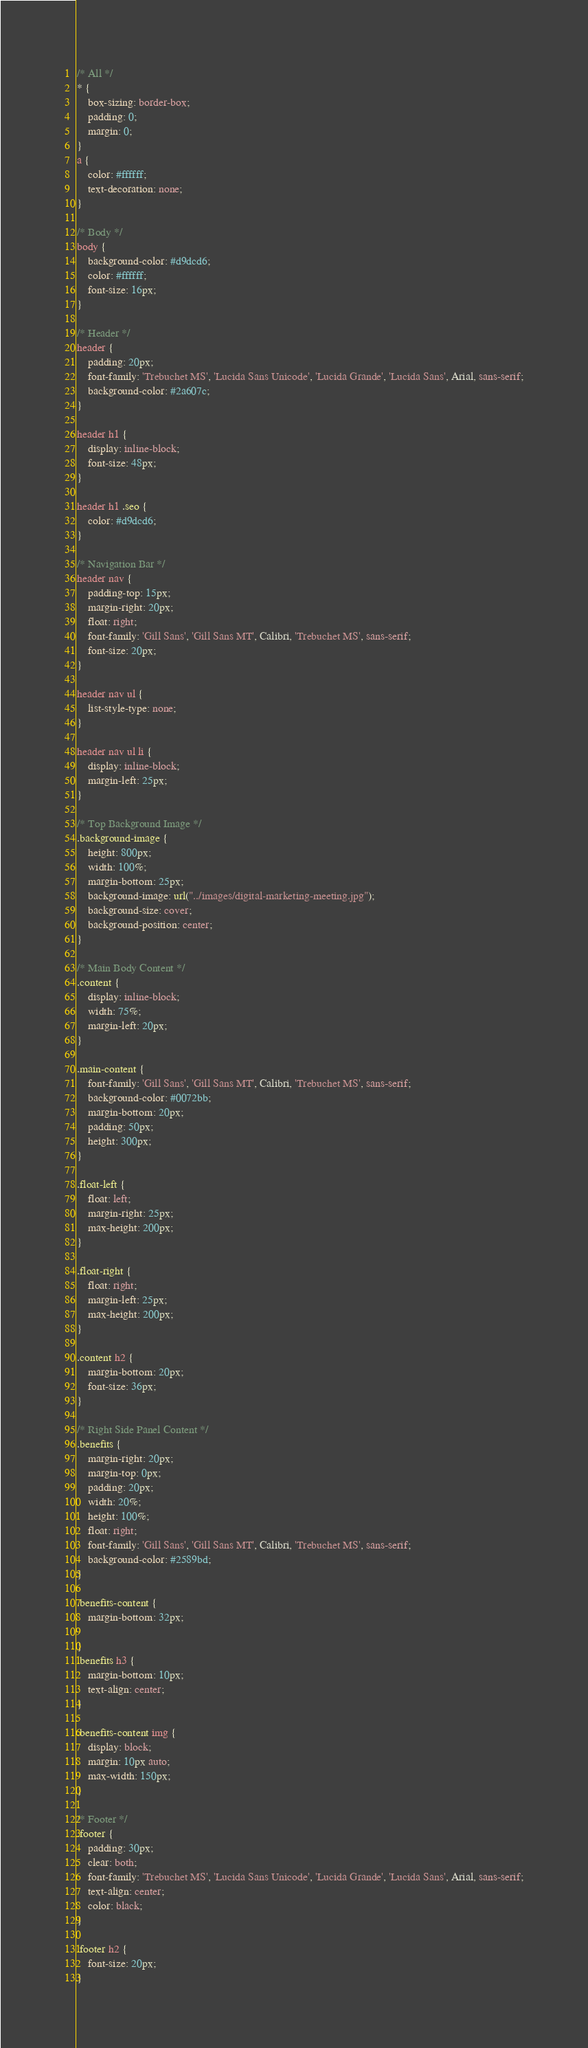<code> <loc_0><loc_0><loc_500><loc_500><_CSS_>/* All */
* {
    box-sizing: border-box;
    padding: 0;
    margin: 0;
}
a {
    color: #ffffff;
    text-decoration: none;
}

/* Body */
body {
    background-color: #d9dcd6;
    color: #ffffff;
    font-size: 16px;
}

/* Header */
header {
    padding: 20px;
    font-family: 'Trebuchet MS', 'Lucida Sans Unicode', 'Lucida Grande', 'Lucida Sans', Arial, sans-serif;
    background-color: #2a607c;
}

header h1 {
    display: inline-block;
    font-size: 48px;
}

header h1 .seo {
    color: #d9dcd6;
}

/* Navigation Bar */
header nav {
    padding-top: 15px;
    margin-right: 20px;
    float: right;
    font-family: 'Gill Sans', 'Gill Sans MT', Calibri, 'Trebuchet MS', sans-serif;
    font-size: 20px;
}

header nav ul {
    list-style-type: none;
}

header nav ul li {
    display: inline-block;
    margin-left: 25px;
}

/* Top Background Image */
.background-image {
    height: 800px;
    width: 100%;
    margin-bottom: 25px;
    background-image: url("../images/digital-marketing-meeting.jpg");
    background-size: cover;
    background-position: center;   
}

/* Main Body Content */
.content {
    display: inline-block;
    width: 75%;
    margin-left: 20px;
}

.main-content {
    font-family: 'Gill Sans', 'Gill Sans MT', Calibri, 'Trebuchet MS', sans-serif;
    background-color: #0072bb;
    margin-bottom: 20px;
    padding: 50px;
    height: 300px;
}

.float-left {
    float: left;
    margin-right: 25px;
    max-height: 200px;
}

.float-right {
    float: right;
    margin-left: 25px;
    max-height: 200px;
}

.content h2 {
    margin-bottom: 20px;
    font-size: 36px;
}

/* Right Side Panel Content */
.benefits {
    margin-right: 20px;
    margin-top: 0px;
    padding: 20px;
    width: 20%;
    height: 100%;
    float: right;
    font-family: 'Gill Sans', 'Gill Sans MT', Calibri, 'Trebuchet MS', sans-serif;
    background-color: #2589bd;
}

.benefits-content {
    margin-bottom: 32px;

}
.benefits h3 {
    margin-bottom: 10px;
    text-align: center;
}

.benefits-content img {
    display: block;
    margin: 10px auto;
    max-width: 150px;
}

/* Footer */
.footer {
    padding: 30px;
    clear: both;
    font-family: 'Trebuchet MS', 'Lucida Sans Unicode', 'Lucida Grande', 'Lucida Sans', Arial, sans-serif;
    text-align: center;
    color: black;
}

.footer h2 {
    font-size: 20px;
}
</code> 